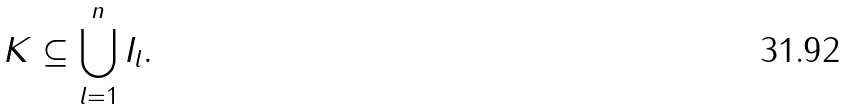<formula> <loc_0><loc_0><loc_500><loc_500>K \subseteq \bigcup _ { l = 1 } ^ { n } I _ { l } .</formula> 